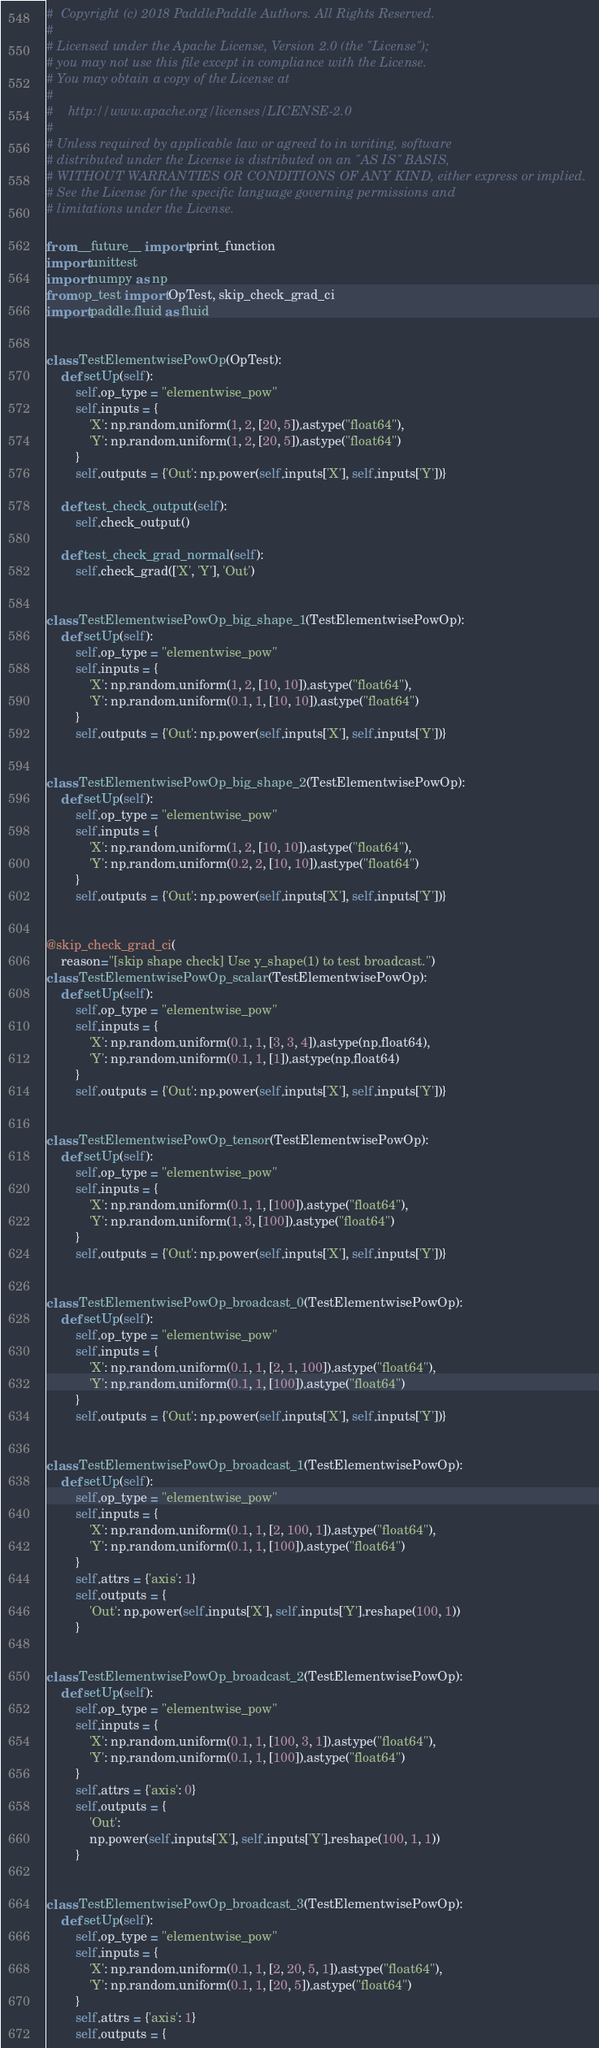<code> <loc_0><loc_0><loc_500><loc_500><_Python_>#  Copyright (c) 2018 PaddlePaddle Authors. All Rights Reserved.
#
# Licensed under the Apache License, Version 2.0 (the "License");
# you may not use this file except in compliance with the License.
# You may obtain a copy of the License at
#
#    http://www.apache.org/licenses/LICENSE-2.0
#
# Unless required by applicable law or agreed to in writing, software
# distributed under the License is distributed on an "AS IS" BASIS,
# WITHOUT WARRANTIES OR CONDITIONS OF ANY KIND, either express or implied.
# See the License for the specific language governing permissions and
# limitations under the License.

from __future__ import print_function
import unittest
import numpy as np
from op_test import OpTest, skip_check_grad_ci
import paddle.fluid as fluid


class TestElementwisePowOp(OpTest):
    def setUp(self):
        self.op_type = "elementwise_pow"
        self.inputs = {
            'X': np.random.uniform(1, 2, [20, 5]).astype("float64"),
            'Y': np.random.uniform(1, 2, [20, 5]).astype("float64")
        }
        self.outputs = {'Out': np.power(self.inputs['X'], self.inputs['Y'])}

    def test_check_output(self):
        self.check_output()

    def test_check_grad_normal(self):
        self.check_grad(['X', 'Y'], 'Out')


class TestElementwisePowOp_big_shape_1(TestElementwisePowOp):
    def setUp(self):
        self.op_type = "elementwise_pow"
        self.inputs = {
            'X': np.random.uniform(1, 2, [10, 10]).astype("float64"),
            'Y': np.random.uniform(0.1, 1, [10, 10]).astype("float64")
        }
        self.outputs = {'Out': np.power(self.inputs['X'], self.inputs['Y'])}


class TestElementwisePowOp_big_shape_2(TestElementwisePowOp):
    def setUp(self):
        self.op_type = "elementwise_pow"
        self.inputs = {
            'X': np.random.uniform(1, 2, [10, 10]).astype("float64"),
            'Y': np.random.uniform(0.2, 2, [10, 10]).astype("float64")
        }
        self.outputs = {'Out': np.power(self.inputs['X'], self.inputs['Y'])}


@skip_check_grad_ci(
    reason="[skip shape check] Use y_shape(1) to test broadcast.")
class TestElementwisePowOp_scalar(TestElementwisePowOp):
    def setUp(self):
        self.op_type = "elementwise_pow"
        self.inputs = {
            'X': np.random.uniform(0.1, 1, [3, 3, 4]).astype(np.float64),
            'Y': np.random.uniform(0.1, 1, [1]).astype(np.float64)
        }
        self.outputs = {'Out': np.power(self.inputs['X'], self.inputs['Y'])}


class TestElementwisePowOp_tensor(TestElementwisePowOp):
    def setUp(self):
        self.op_type = "elementwise_pow"
        self.inputs = {
            'X': np.random.uniform(0.1, 1, [100]).astype("float64"),
            'Y': np.random.uniform(1, 3, [100]).astype("float64")
        }
        self.outputs = {'Out': np.power(self.inputs['X'], self.inputs['Y'])}


class TestElementwisePowOp_broadcast_0(TestElementwisePowOp):
    def setUp(self):
        self.op_type = "elementwise_pow"
        self.inputs = {
            'X': np.random.uniform(0.1, 1, [2, 1, 100]).astype("float64"),
            'Y': np.random.uniform(0.1, 1, [100]).astype("float64")
        }
        self.outputs = {'Out': np.power(self.inputs['X'], self.inputs['Y'])}


class TestElementwisePowOp_broadcast_1(TestElementwisePowOp):
    def setUp(self):
        self.op_type = "elementwise_pow"
        self.inputs = {
            'X': np.random.uniform(0.1, 1, [2, 100, 1]).astype("float64"),
            'Y': np.random.uniform(0.1, 1, [100]).astype("float64")
        }
        self.attrs = {'axis': 1}
        self.outputs = {
            'Out': np.power(self.inputs['X'], self.inputs['Y'].reshape(100, 1))
        }


class TestElementwisePowOp_broadcast_2(TestElementwisePowOp):
    def setUp(self):
        self.op_type = "elementwise_pow"
        self.inputs = {
            'X': np.random.uniform(0.1, 1, [100, 3, 1]).astype("float64"),
            'Y': np.random.uniform(0.1, 1, [100]).astype("float64")
        }
        self.attrs = {'axis': 0}
        self.outputs = {
            'Out':
            np.power(self.inputs['X'], self.inputs['Y'].reshape(100, 1, 1))
        }


class TestElementwisePowOp_broadcast_3(TestElementwisePowOp):
    def setUp(self):
        self.op_type = "elementwise_pow"
        self.inputs = {
            'X': np.random.uniform(0.1, 1, [2, 20, 5, 1]).astype("float64"),
            'Y': np.random.uniform(0.1, 1, [20, 5]).astype("float64")
        }
        self.attrs = {'axis': 1}
        self.outputs = {</code> 